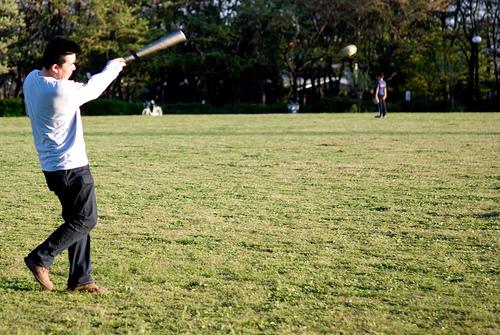Is this an official baseball game?
Answer briefly. No. Are the players too far away from each other?
Write a very short answer. Yes. Who will catch the ball?
Short answer required. Man. Is the guy holding the bat wearing a proper outfit for the game?
Be succinct. No. What type of mitt do you see?
Answer briefly. Baseball. Has this baseball been pitched?
Keep it brief. Yes. Is the batter wearing a helmet?
Concise answer only. No. What color are the man's pants?
Keep it brief. Black. 